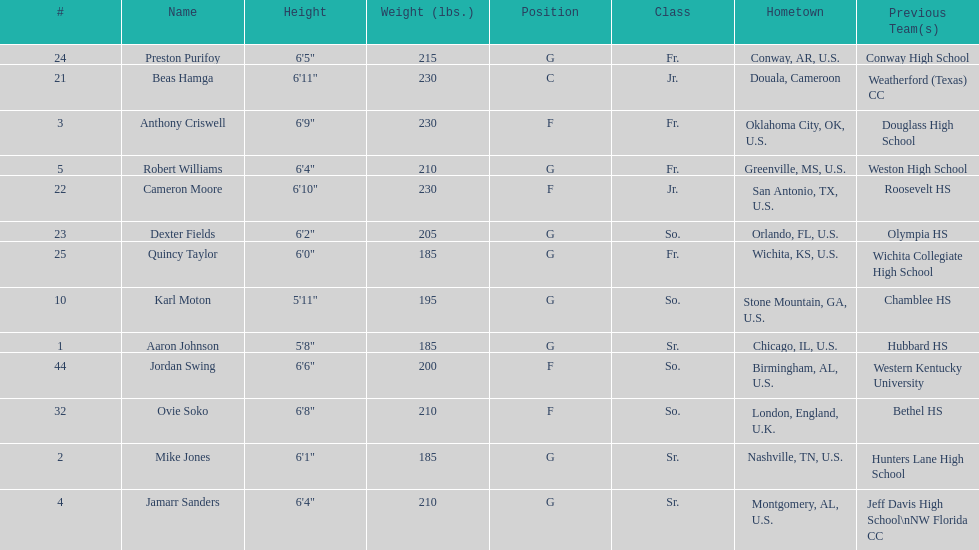How many total forwards are on the team? 4. 